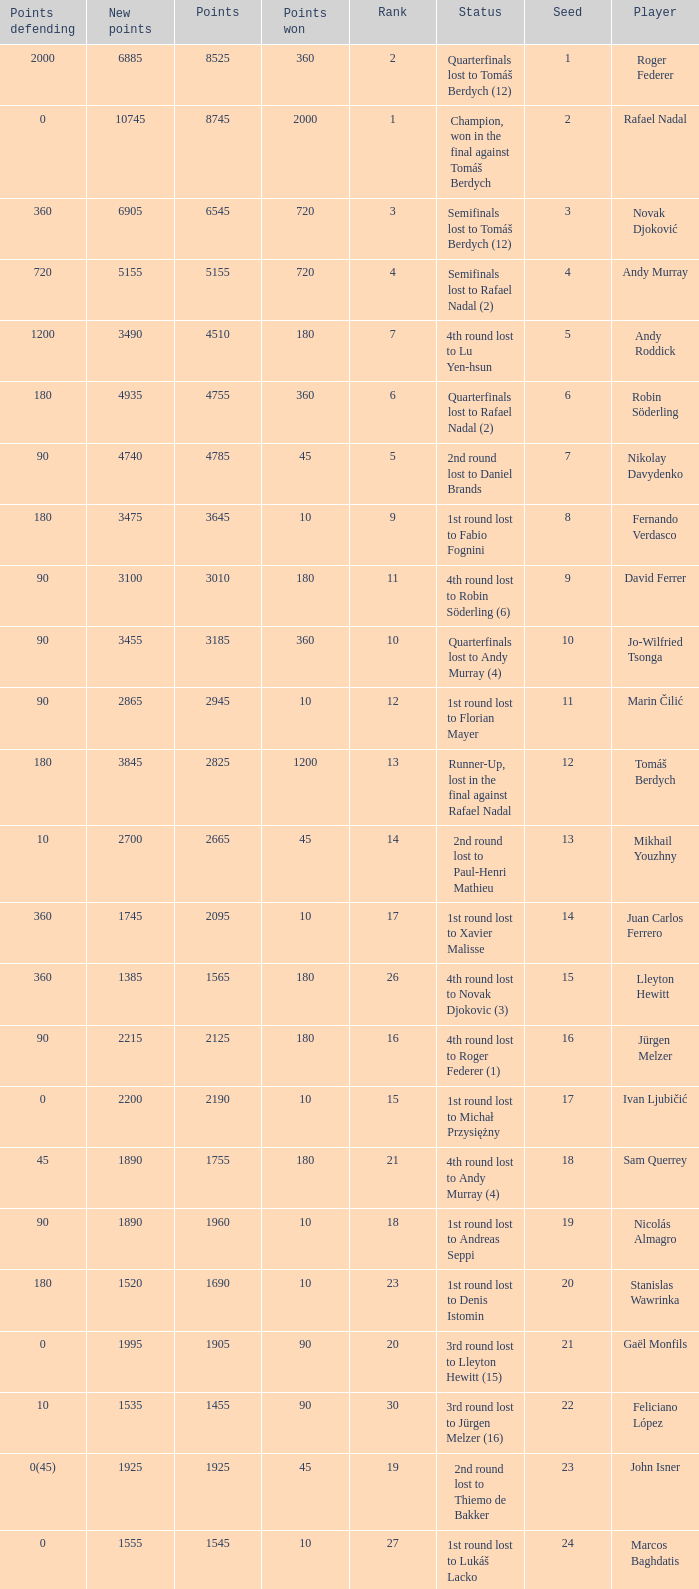Name the status for points 3185 Quarterfinals lost to Andy Murray (4). Would you mind parsing the complete table? {'header': ['Points defending', 'New points', 'Points', 'Points won', 'Rank', 'Status', 'Seed', 'Player'], 'rows': [['2000', '6885', '8525', '360', '2', 'Quarterfinals lost to Tomáš Berdych (12)', '1', 'Roger Federer'], ['0', '10745', '8745', '2000', '1', 'Champion, won in the final against Tomáš Berdych', '2', 'Rafael Nadal'], ['360', '6905', '6545', '720', '3', 'Semifinals lost to Tomáš Berdych (12)', '3', 'Novak Djoković'], ['720', '5155', '5155', '720', '4', 'Semifinals lost to Rafael Nadal (2)', '4', 'Andy Murray'], ['1200', '3490', '4510', '180', '7', '4th round lost to Lu Yen-hsun', '5', 'Andy Roddick'], ['180', '4935', '4755', '360', '6', 'Quarterfinals lost to Rafael Nadal (2)', '6', 'Robin Söderling'], ['90', '4740', '4785', '45', '5', '2nd round lost to Daniel Brands', '7', 'Nikolay Davydenko'], ['180', '3475', '3645', '10', '9', '1st round lost to Fabio Fognini', '8', 'Fernando Verdasco'], ['90', '3100', '3010', '180', '11', '4th round lost to Robin Söderling (6)', '9', 'David Ferrer'], ['90', '3455', '3185', '360', '10', 'Quarterfinals lost to Andy Murray (4)', '10', 'Jo-Wilfried Tsonga'], ['90', '2865', '2945', '10', '12', '1st round lost to Florian Mayer', '11', 'Marin Čilić'], ['180', '3845', '2825', '1200', '13', 'Runner-Up, lost in the final against Rafael Nadal', '12', 'Tomáš Berdych'], ['10', '2700', '2665', '45', '14', '2nd round lost to Paul-Henri Mathieu', '13', 'Mikhail Youzhny'], ['360', '1745', '2095', '10', '17', '1st round lost to Xavier Malisse', '14', 'Juan Carlos Ferrero'], ['360', '1385', '1565', '180', '26', '4th round lost to Novak Djokovic (3)', '15', 'Lleyton Hewitt'], ['90', '2215', '2125', '180', '16', '4th round lost to Roger Federer (1)', '16', 'Jürgen Melzer'], ['0', '2200', '2190', '10', '15', '1st round lost to Michał Przysiężny', '17', 'Ivan Ljubičić'], ['45', '1890', '1755', '180', '21', '4th round lost to Andy Murray (4)', '18', 'Sam Querrey'], ['90', '1890', '1960', '10', '18', '1st round lost to Andreas Seppi', '19', 'Nicolás Almagro'], ['180', '1520', '1690', '10', '23', '1st round lost to Denis Istomin', '20', 'Stanislas Wawrinka'], ['0', '1995', '1905', '90', '20', '3rd round lost to Lleyton Hewitt (15)', '21', 'Gaël Monfils'], ['10', '1535', '1455', '90', '30', '3rd round lost to Jürgen Melzer (16)', '22', 'Feliciano López'], ['0(45)', '1925', '1925', '45', '19', '2nd round lost to Thiemo de Bakker', '23', 'John Isner'], ['0', '1555', '1545', '10', '27', '1st round lost to Lukáš Lacko', '24', 'Marcos Baghdatis'], ['0(20)', '1722', '1652', '90', '24', '3rd round lost to Robin Söderling (6)', '25', 'Thomaz Bellucci'], ['180', '1215', '1305', '90', '32', '3rd round lost to Andy Murray (4)', '26', 'Gilles Simon'], ['90', '1405', '1405', '90', '31', '3rd round lost to Novak Djokovic (3)', '28', 'Albert Montañés'], ['90', '1230', '1230', '90', '35', '3rd round lost to Andy Roddick (5)', '29', 'Philipp Kohlschreiber'], ['90', '1075', '1155', '10', '36', '1st round lost to Peter Luczak', '30', 'Tommy Robredo'], ['45', '1115', '1070', '90', '37', '3rd round lost to Daniel Brands', '31', 'Victor Hănescu'], ['10', '1229', '1059', '180', '38', '4th round lost to Jo-Wilfried Tsonga (10)', '32', 'Julien Benneteau']]} 